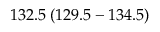Convert formula to latex. <formula><loc_0><loc_0><loc_500><loc_500>1 3 2 . 5 \, ( 1 2 9 . 5 - 1 3 4 . 5 )</formula> 